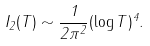<formula> <loc_0><loc_0><loc_500><loc_500>I _ { 2 } ( T ) \sim \frac { 1 } { 2 \pi ^ { 2 } } ( \log T ) ^ { 4 } .</formula> 